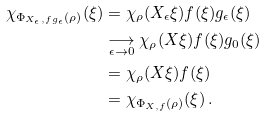Convert formula to latex. <formula><loc_0><loc_0><loc_500><loc_500>\chi _ { \Phi _ { X _ { \epsilon } , f g _ { \epsilon } } ( \rho ) } ( \xi ) & = \chi _ { \rho } ( X _ { \epsilon } \xi ) f ( \xi ) g _ { \epsilon } ( \xi ) \\ & \underset { \epsilon \rightarrow 0 } { \longrightarrow } \chi _ { \rho } ( X \xi ) f ( \xi ) g _ { 0 } ( \xi ) \\ & = \chi _ { \rho } ( X \xi ) f ( \xi ) \\ & = \chi _ { \Phi _ { X , f } ( \rho ) } ( \xi ) \, .</formula> 